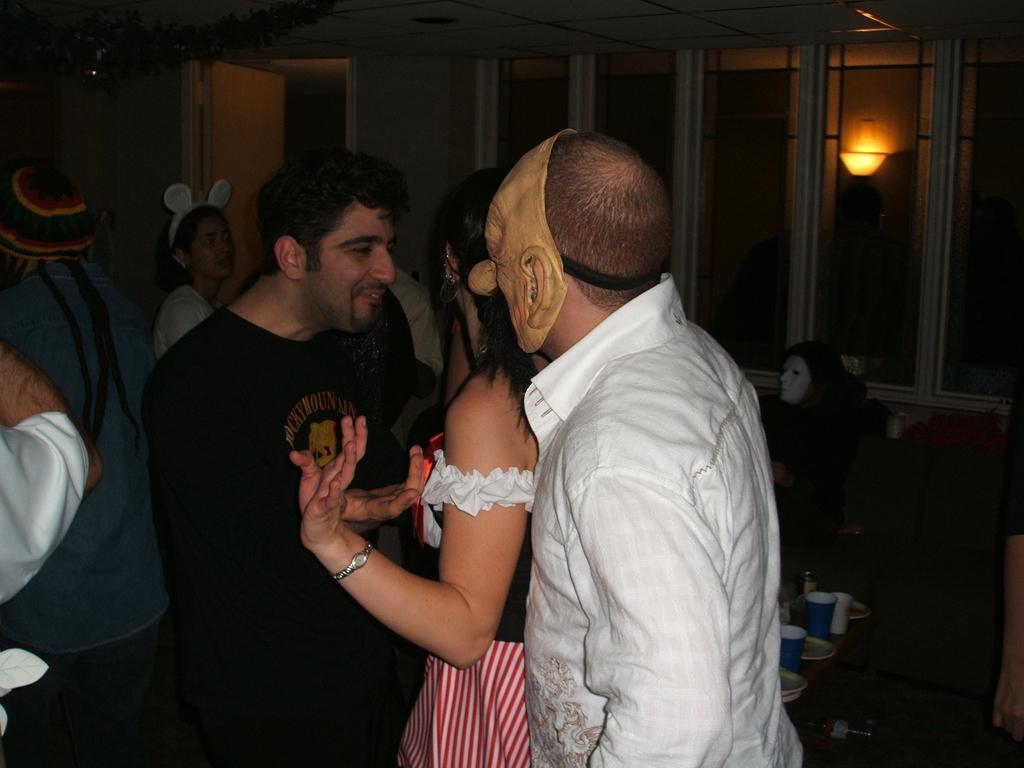Can you describe this image briefly? In the picture I can see a few persons. There is a man on the right side is wearing a white color shirt and there is a mask on his face. There is another man on the left side is wearing a black color T-shirt and looks like there is a smile on his face. I can see another person with the mask on the right side. I can see the plates and glasses on the table which is on the floor. In the background, I can see the glass windows. I can see the door on the top left side of the picture. 